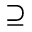Convert formula to latex. <formula><loc_0><loc_0><loc_500><loc_500>\supseteq</formula> 